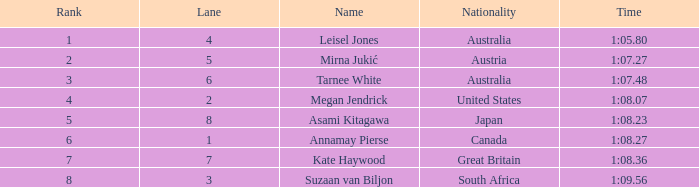What is the Nationality of the Swimmer in Lane 4 or larger with a Rank of 5 or more? Great Britain. 